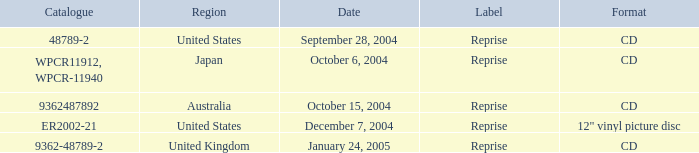Name the date that is a cd September 28, 2004, October 6, 2004, October 15, 2004, January 24, 2005. 